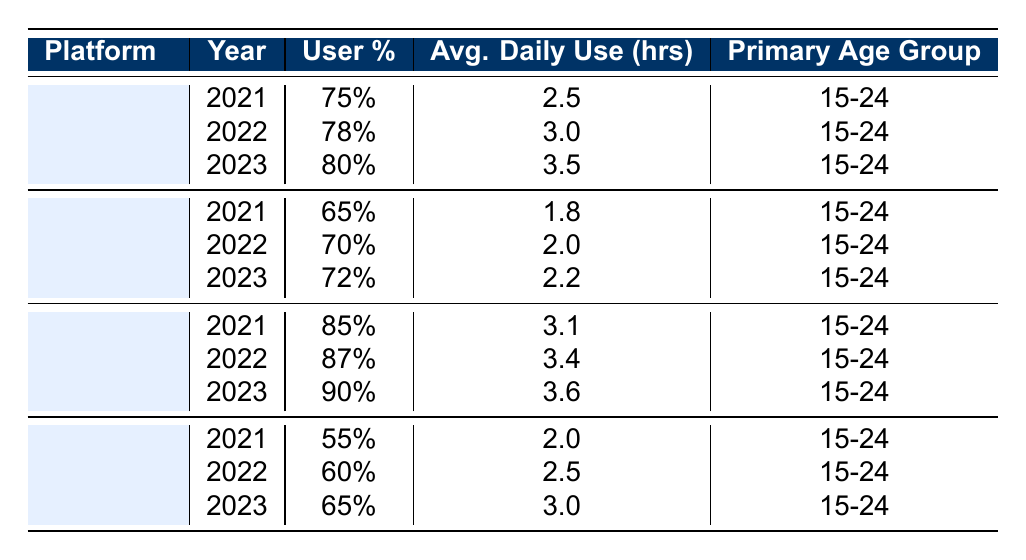What is the user percentage for YouTube in 2023? The table shows that the user percentage for YouTube in 2023 is explicitly listed as 90%.
Answer: 90% What is the average daily use time for KakaoTalk in 2022? The entry for KakaoTalk in 2022 indicates that the average daily use time is 3.0 hours.
Answer: 3.0 hours Is TikTok less popular than Instagram in 2021 based on user percentage? In 2021, TikTok's user percentage is 55%, while Instagram's is 65%. Since 55% is less than 65%, TikTok is indeed less popular than Instagram.
Answer: Yes What is the increase in user percentage for Instagram from 2021 to 2023? The user percentage for Instagram in 2021 is 65% and in 2023 it is 72%. The increase is calculated as 72% - 65% = 7%.
Answer: 7% Which platform has the highest average daily use hours in 2023? In 2023, YouTube has the highest average daily use hours at 3.6 hours, while KakaoTalk has 3.5 hours, and TikTok has 3.0 hours.
Answer: YouTube What are the average daily use hours for all platforms combined in 2022? The average daily use hours in 2022 for each platform are KakaoTalk (3.0), Instagram (2.0), YouTube (3.4), and TikTok (2.5). The total is 3.0 + 2.0 + 3.4 + 2.5 = 10.9 hours. Since there are 4 platforms, the average is 10.9 / 4 = 2.725.
Answer: 2.725 hours Is the primary age group for all listed platforms the same? The table indicates that all platforms have the same primary age group listed as 15-24. Therefore, it is true that the primary age group is the same for all platforms.
Answer: Yes What is the trend in user percentage for YouTube from 2021 to 2023? The user percentage for YouTube is 85% in 2021, increases to 87% in 2022, and further increases to 90% in 2023. Therefore, the trend shows a consistent increase over the years.
Answer: Consistent increase 